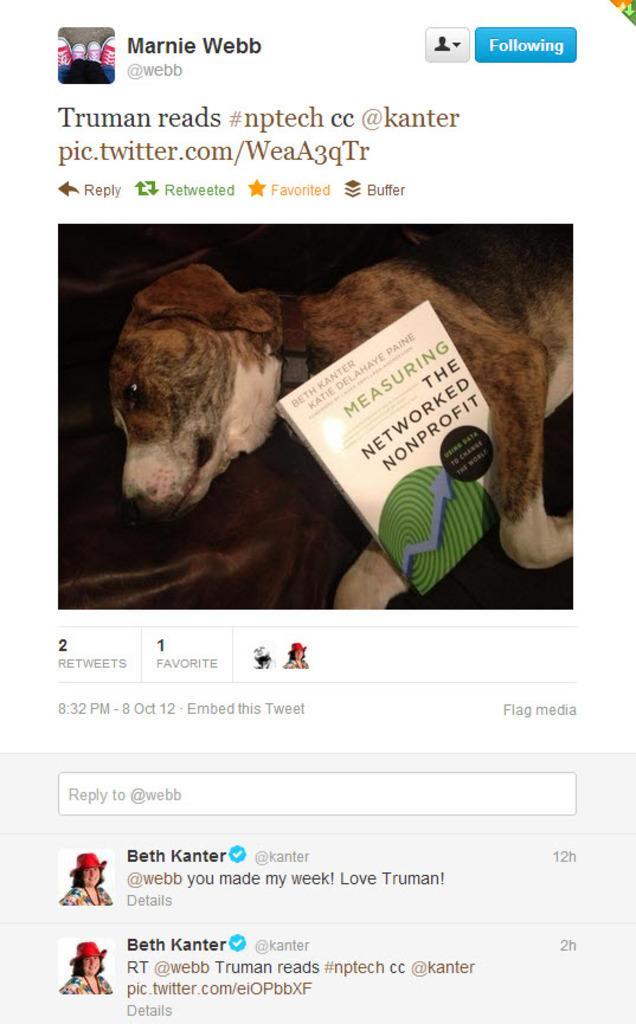Please provide a concise description of this image. In this image I can see the screenshot. I can see the book and the dog is in brown and cream color and something is written on it. 